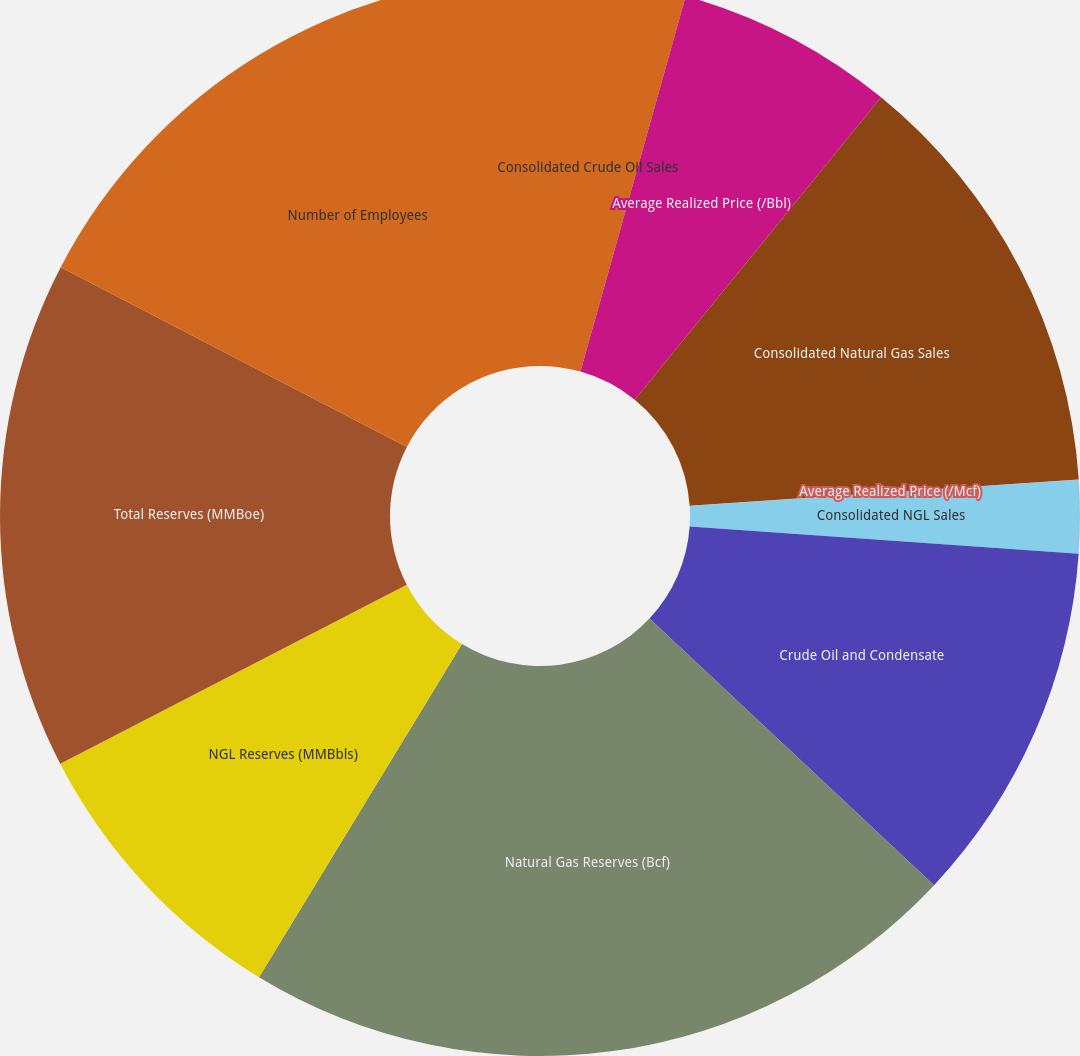Convert chart. <chart><loc_0><loc_0><loc_500><loc_500><pie_chart><fcel>Consolidated Crude Oil Sales<fcel>Average Realized Price (/Bbl)<fcel>Consolidated Natural Gas Sales<fcel>Average Realized Price (/Mcf)<fcel>Consolidated NGL Sales<fcel>Crude Oil and Condensate<fcel>Natural Gas Reserves (Bcf)<fcel>NGL Reserves (MMBbls)<fcel>Total Reserves (MMBoe)<fcel>Number of Employees<nl><fcel>4.35%<fcel>6.53%<fcel>13.04%<fcel>0.01%<fcel>2.18%<fcel>10.87%<fcel>21.73%<fcel>8.7%<fcel>15.21%<fcel>17.38%<nl></chart> 